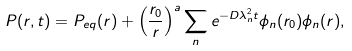<formula> <loc_0><loc_0><loc_500><loc_500>P ( r , t ) = P _ { e q } ( r ) + \left ( \frac { r _ { 0 } } { r } \right ) ^ { a } \sum _ { n } e ^ { - D \lambda _ { n } ^ { 2 } t } \phi _ { n } ( r _ { 0 } ) \phi _ { n } ( r ) ,</formula> 